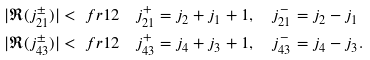Convert formula to latex. <formula><loc_0><loc_0><loc_500><loc_500>| \Re ( j _ { 2 1 } ^ { \pm } ) | & < \ f r { 1 } { 2 } \quad j _ { 2 1 } ^ { + } = j _ { 2 } + j _ { 1 } + 1 , \quad j _ { 2 1 } ^ { - } = j _ { 2 } - j _ { 1 } \\ | \Re ( j _ { 4 3 } ^ { \pm } ) | & < \ f r { 1 } { 2 } \quad j _ { 4 3 } ^ { + } = j _ { 4 } + j _ { 3 } + 1 , \quad j _ { 4 3 } ^ { - } = j _ { 4 } - j _ { 3 } .</formula> 